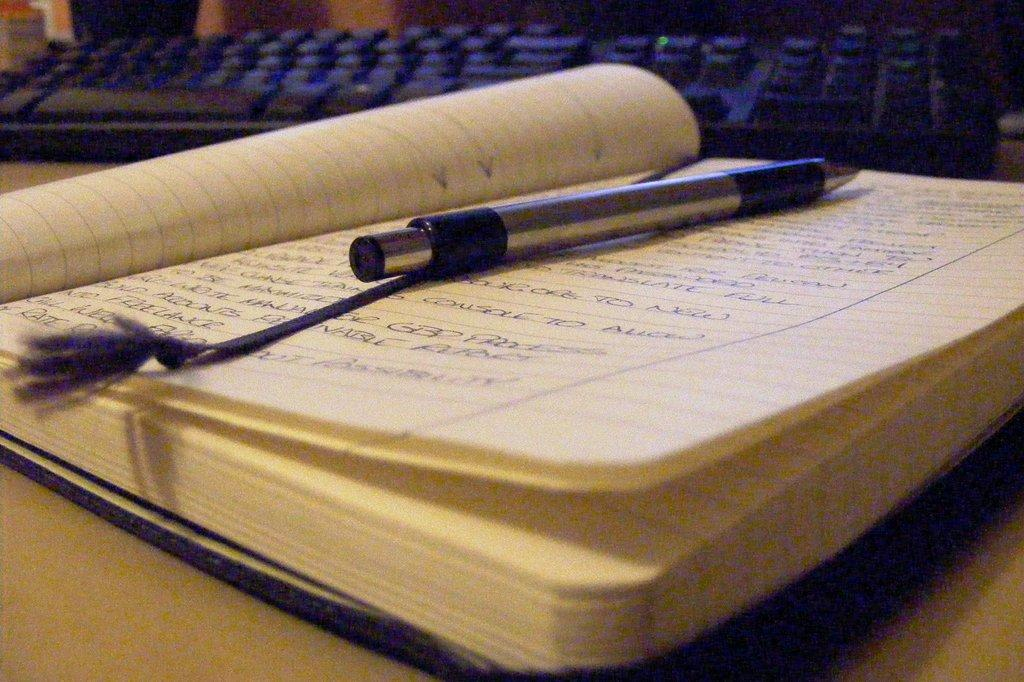What object can be seen on top of the book in the image? There is a pen on the book in the image. What other object is present on the table along with the book and pen? There is a keyboard in the image. Where are the book, pen, and keyboard located in the image? They are placed on a table. What type of stitch is being used to hold the clouds together in the image? There are no clouds or stitching present in the image; it features a book, pen, and keyboard on a table. 